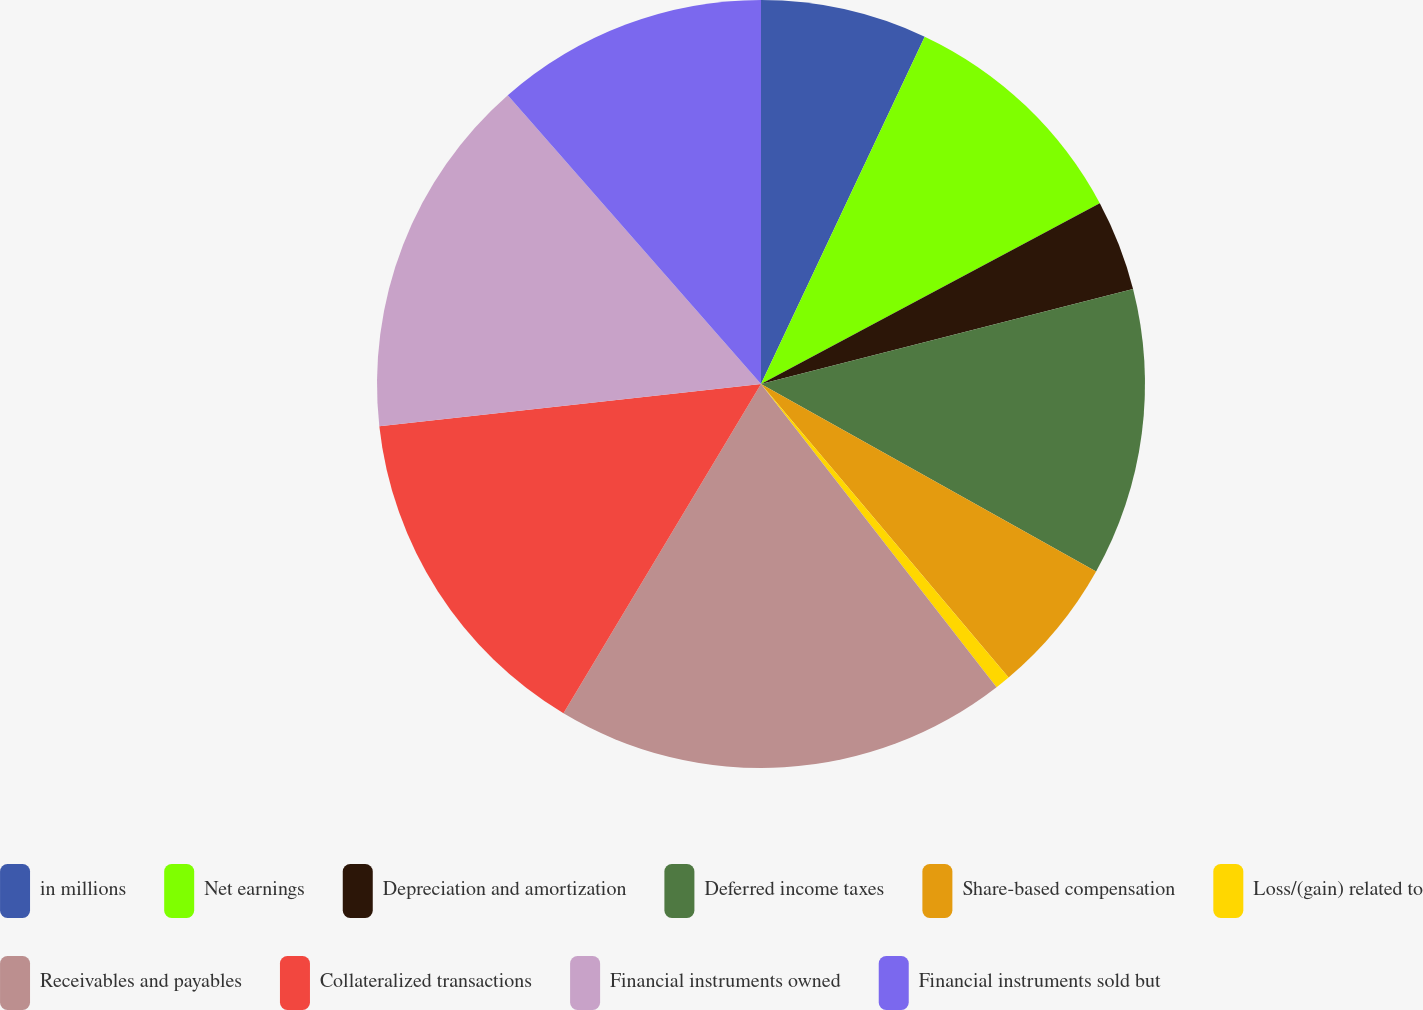Convert chart to OTSL. <chart><loc_0><loc_0><loc_500><loc_500><pie_chart><fcel>in millions<fcel>Net earnings<fcel>Depreciation and amortization<fcel>Deferred income taxes<fcel>Share-based compensation<fcel>Loss/(gain) related to<fcel>Receivables and payables<fcel>Collateralized transactions<fcel>Financial instruments owned<fcel>Financial instruments sold but<nl><fcel>7.01%<fcel>10.19%<fcel>3.82%<fcel>12.1%<fcel>5.73%<fcel>0.64%<fcel>19.11%<fcel>14.65%<fcel>15.29%<fcel>11.46%<nl></chart> 